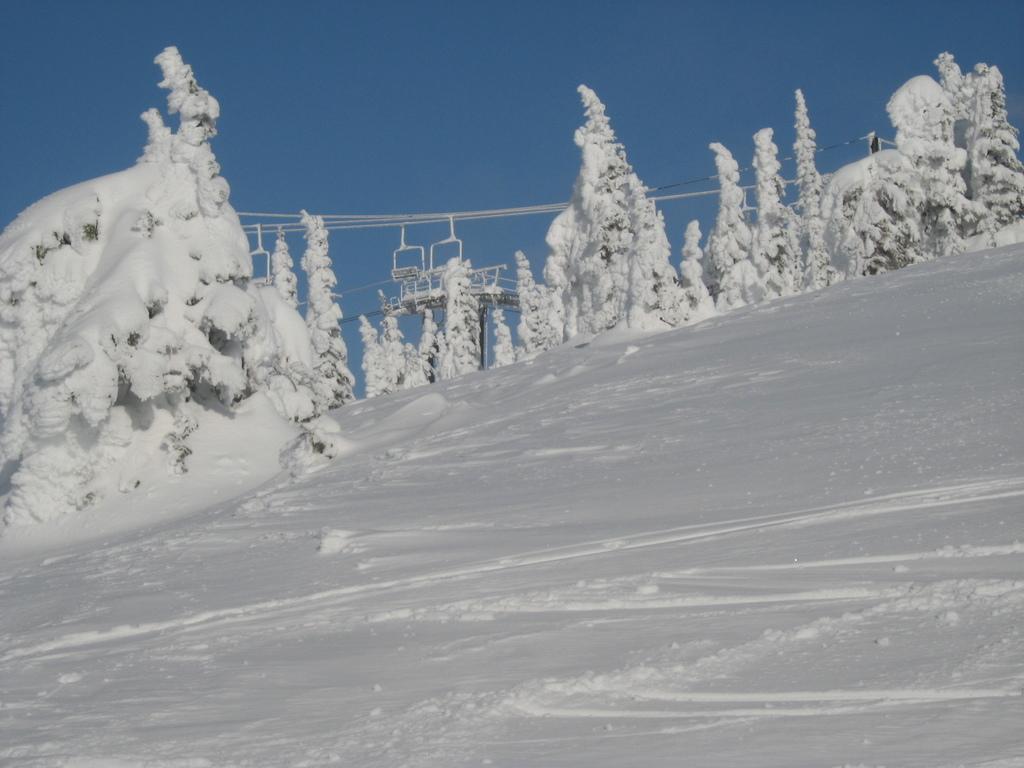Can you describe this image briefly? In this image we can see some trees to which snow is formed and at the background of the image there are some wires and clear sky. 